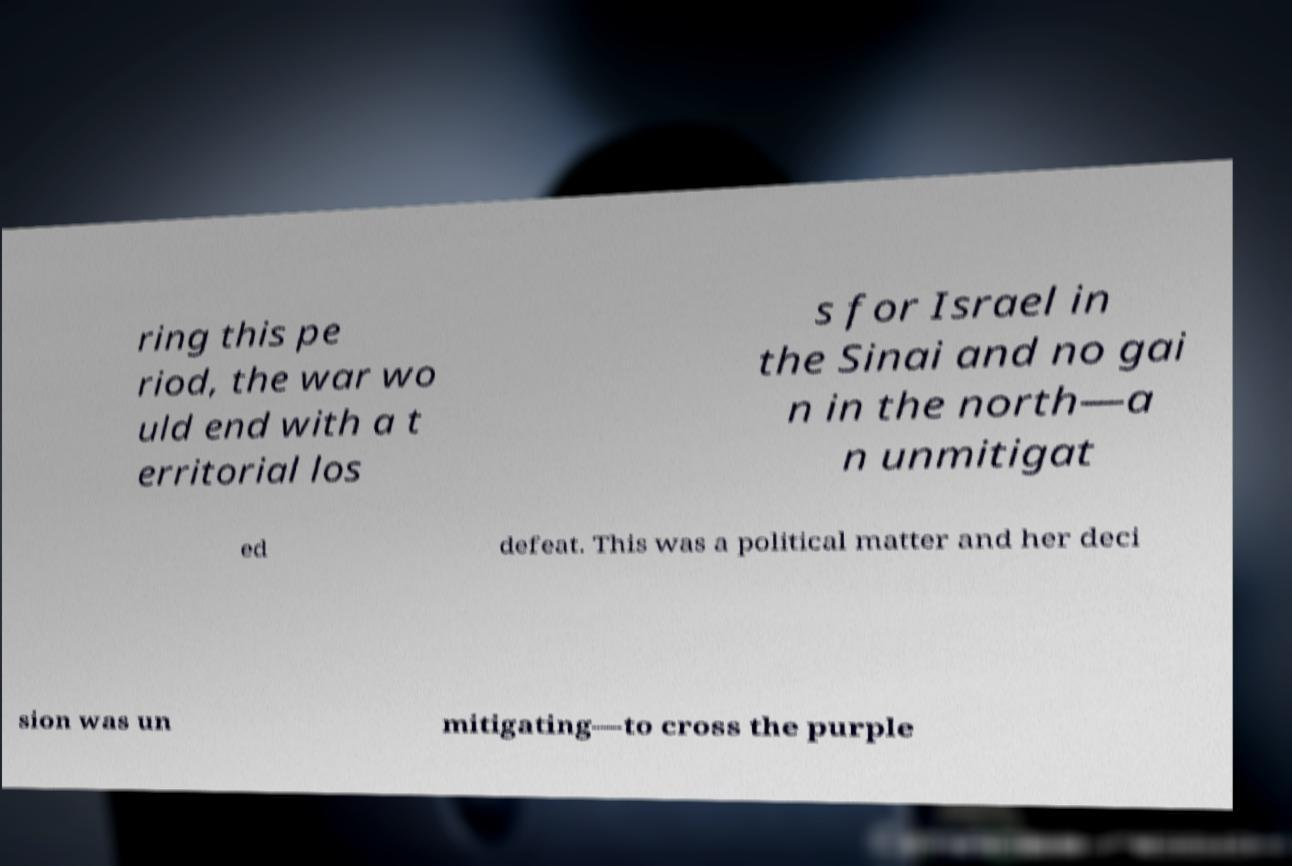There's text embedded in this image that I need extracted. Can you transcribe it verbatim? ring this pe riod, the war wo uld end with a t erritorial los s for Israel in the Sinai and no gai n in the north—a n unmitigat ed defeat. This was a political matter and her deci sion was un mitigating—to cross the purple 